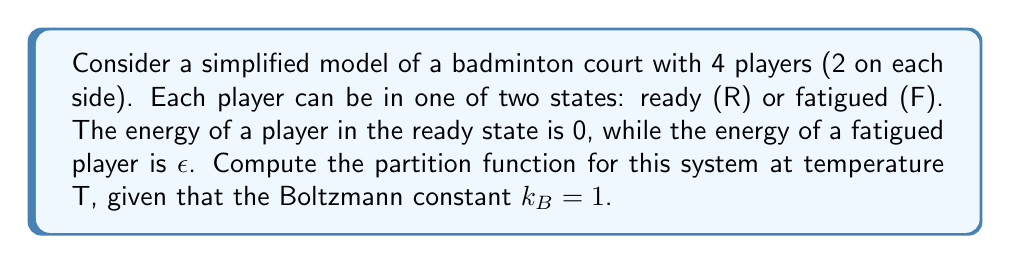Provide a solution to this math problem. Let's approach this step-by-step:

1) The partition function Z is given by:

   $$Z = \sum_i e^{-\beta E_i}$$

   where $\beta = \frac{1}{k_B T} = \frac{1}{T}$ (since $k_B = 1$), and $E_i$ is the energy of each microstate.

2) In our system, each player can be in one of two states (R or F), and there are 4 players. So, the total number of microstates is $2^4 = 16$.

3) Let's consider the possible energy states:
   - 0 fatigued players: $E_0 = 0$
   - 1 fatigued player: $E_1 = \epsilon$
   - 2 fatigued players: $E_2 = 2\epsilon$
   - 3 fatigued players: $E_3 = 3\epsilon$
   - 4 fatigued players: $E_4 = 4\epsilon$

4) Now, let's count the number of ways to achieve each energy state:
   - 0 fatigued players: $\binom{4}{0} = 1$ way
   - 1 fatigued player: $\binom{4}{1} = 4$ ways
   - 2 fatigued players: $\binom{4}{2} = 6$ ways
   - 3 fatigued players: $\binom{4}{3} = 4$ ways
   - 4 fatigued players: $\binom{4}{4} = 1$ way

5) We can now write out our partition function:

   $$Z = 1 \cdot e^{-\beta \cdot 0} + 4 \cdot e^{-\beta \epsilon} + 6 \cdot e^{-2\beta \epsilon} + 4 \cdot e^{-3\beta \epsilon} + 1 \cdot e^{-4\beta \epsilon}$$

6) Simplify:

   $$Z = 1 + 4e^{-\epsilon/T} + 6e^{-2\epsilon/T} + 4e^{-3\epsilon/T} + e^{-4\epsilon/T}$$

This is our final partition function.
Answer: $Z = 1 + 4e^{-\epsilon/T} + 6e^{-2\epsilon/T} + 4e^{-3\epsilon/T} + e^{-4\epsilon/T}$ 